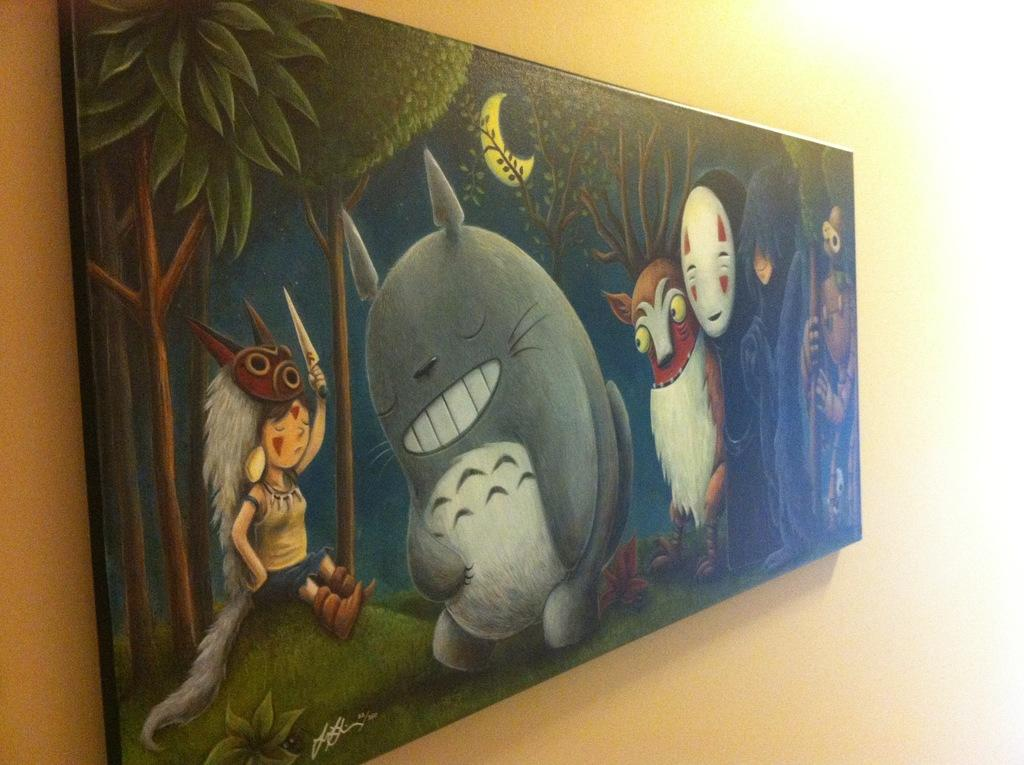What is the main subject of the image? The main subject of the image is a painting. What type of content is depicted in the painting? The painting contains cartoons. Where is the painting located in the image? The painting is placed on a wall. What color is the bomb in the painting? There is no bomb present in the painting; it contains cartoons. 